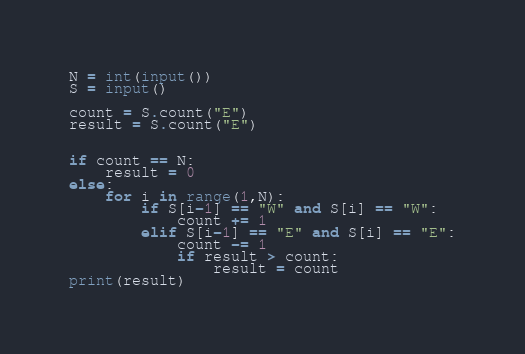<code> <loc_0><loc_0><loc_500><loc_500><_Python_>N = int(input())
S = input()

count = S.count("E")
result = S.count("E")


if count == N:
    result = 0
else:
    for i in range(1,N):
        if S[i-1] == "W" and S[i] == "W":
            count += 1
        elif S[i-1] == "E" and S[i] == "E":
            count -= 1
            if result > count:
                result = count
print(result)</code> 